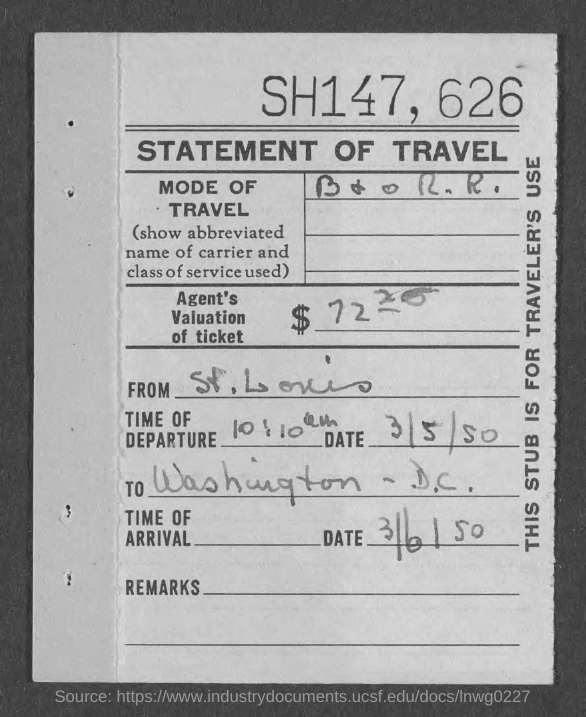What type of documentation is this?
Keep it short and to the point. STATEMENT OF TRAVEL. What is written at the top of the page?
Offer a very short reply. SH147, 626. To which place is the travel?
Provide a succinct answer. Washington - D.C. Where is the travel from?
Offer a very short reply. St. Louis. What is the time of departure?
Offer a terse response. 10:10 am. 